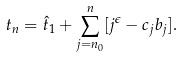Convert formula to latex. <formula><loc_0><loc_0><loc_500><loc_500>t _ { n } = \hat { t } _ { 1 } + \sum _ { j = n _ { 0 } } ^ { n } [ j ^ { \epsilon } - c _ { j } b _ { j } ] .</formula> 